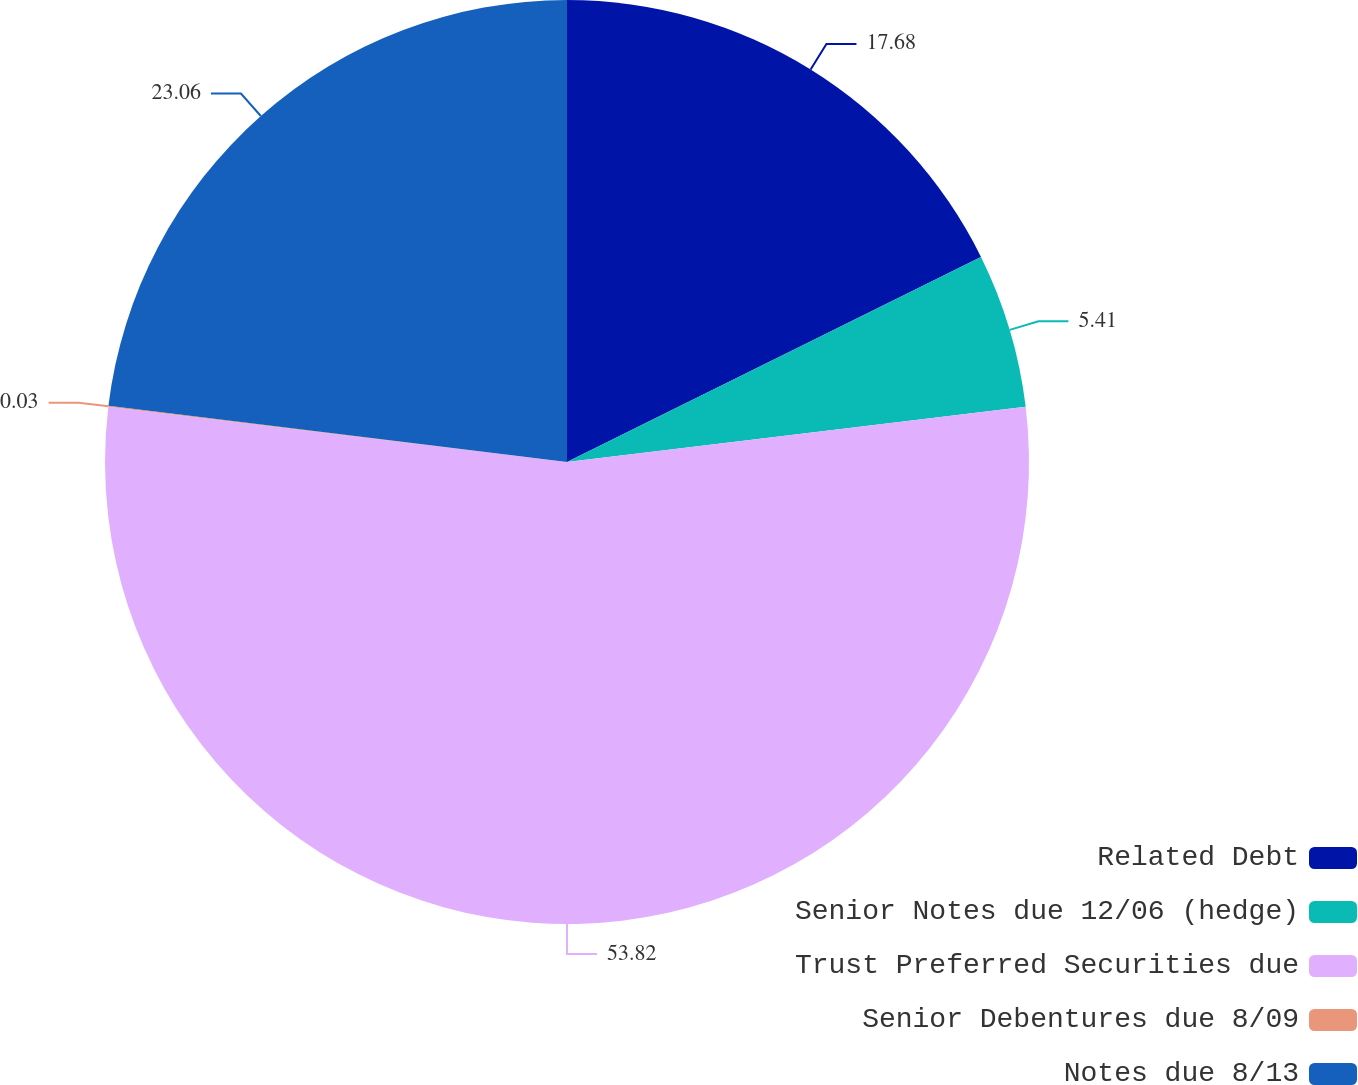Convert chart. <chart><loc_0><loc_0><loc_500><loc_500><pie_chart><fcel>Related Debt<fcel>Senior Notes due 12/06 (hedge)<fcel>Trust Preferred Securities due<fcel>Senior Debentures due 8/09<fcel>Notes due 8/13<nl><fcel>17.68%<fcel>5.41%<fcel>53.82%<fcel>0.03%<fcel>23.06%<nl></chart> 